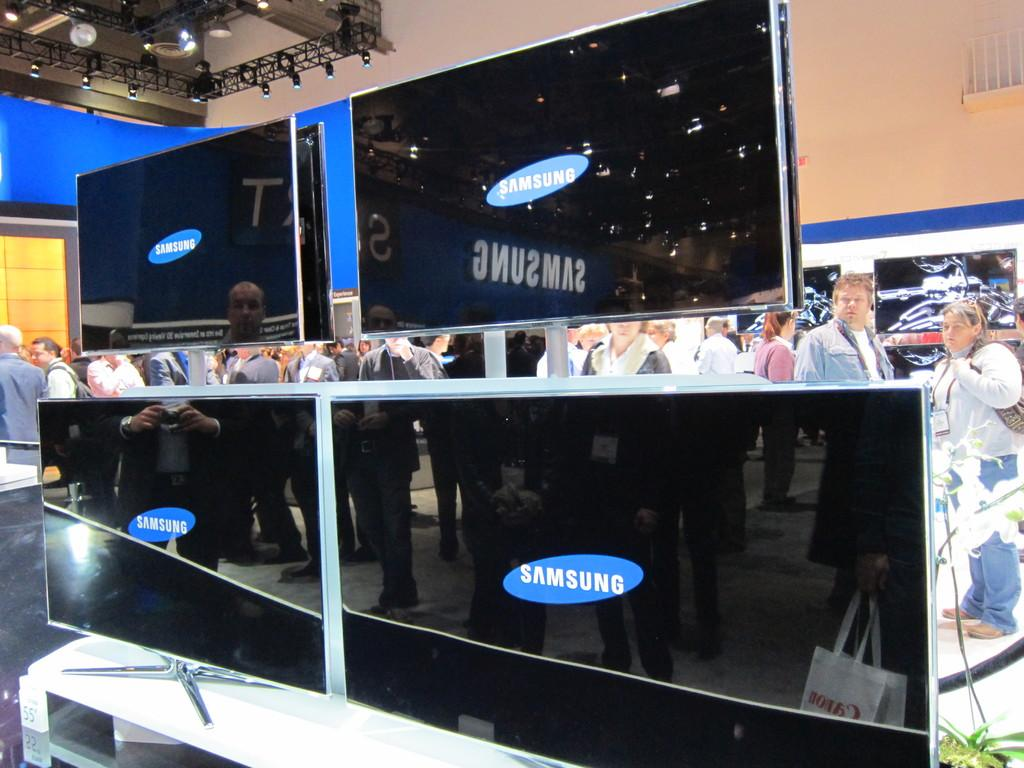<image>
Summarize the visual content of the image. Many people are standing behind a Samsung Television display. 